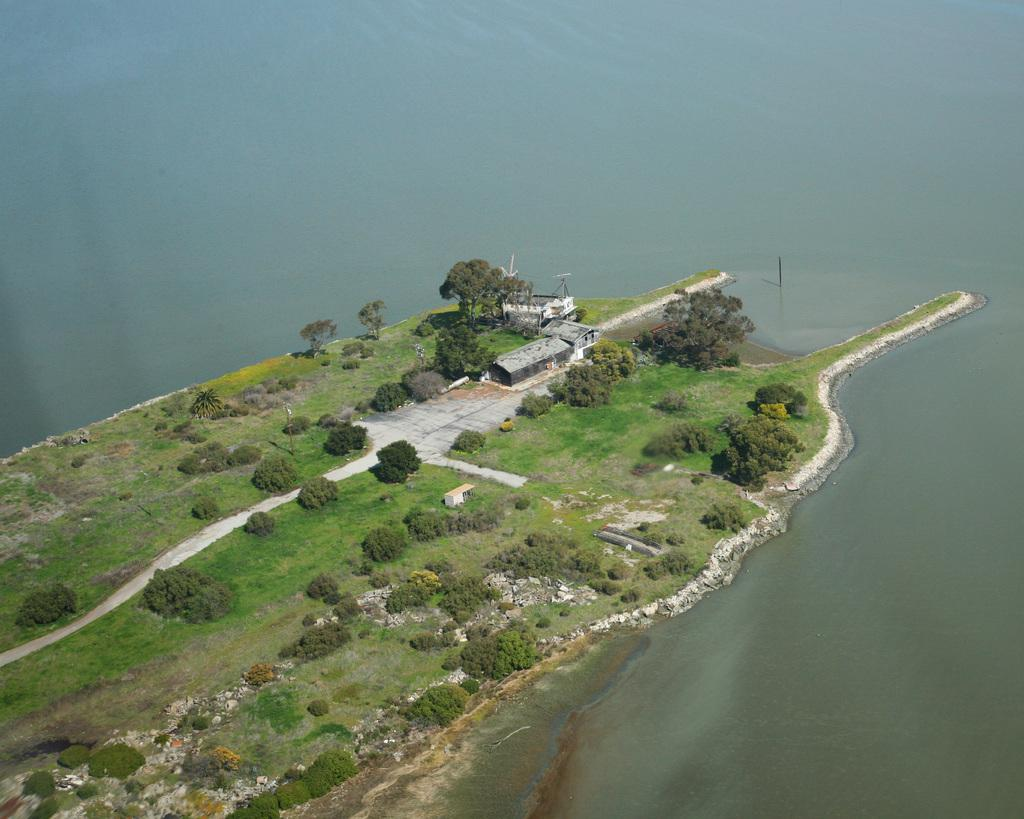What type of structures can be seen in the image? There are houses in the image. What type of vegetation is present in the image? There are trees, plants, and grass in the image. What kind of surface is visible in the image? There is a path in the image. What natural element can be seen in the image? There is water visible in the image. What type of straw is used to turn the page in the image? There is no straw or page present in the image. How does the image change when you look at it from a different angle? The image does not change when viewed from different angles, as it is a static representation. 